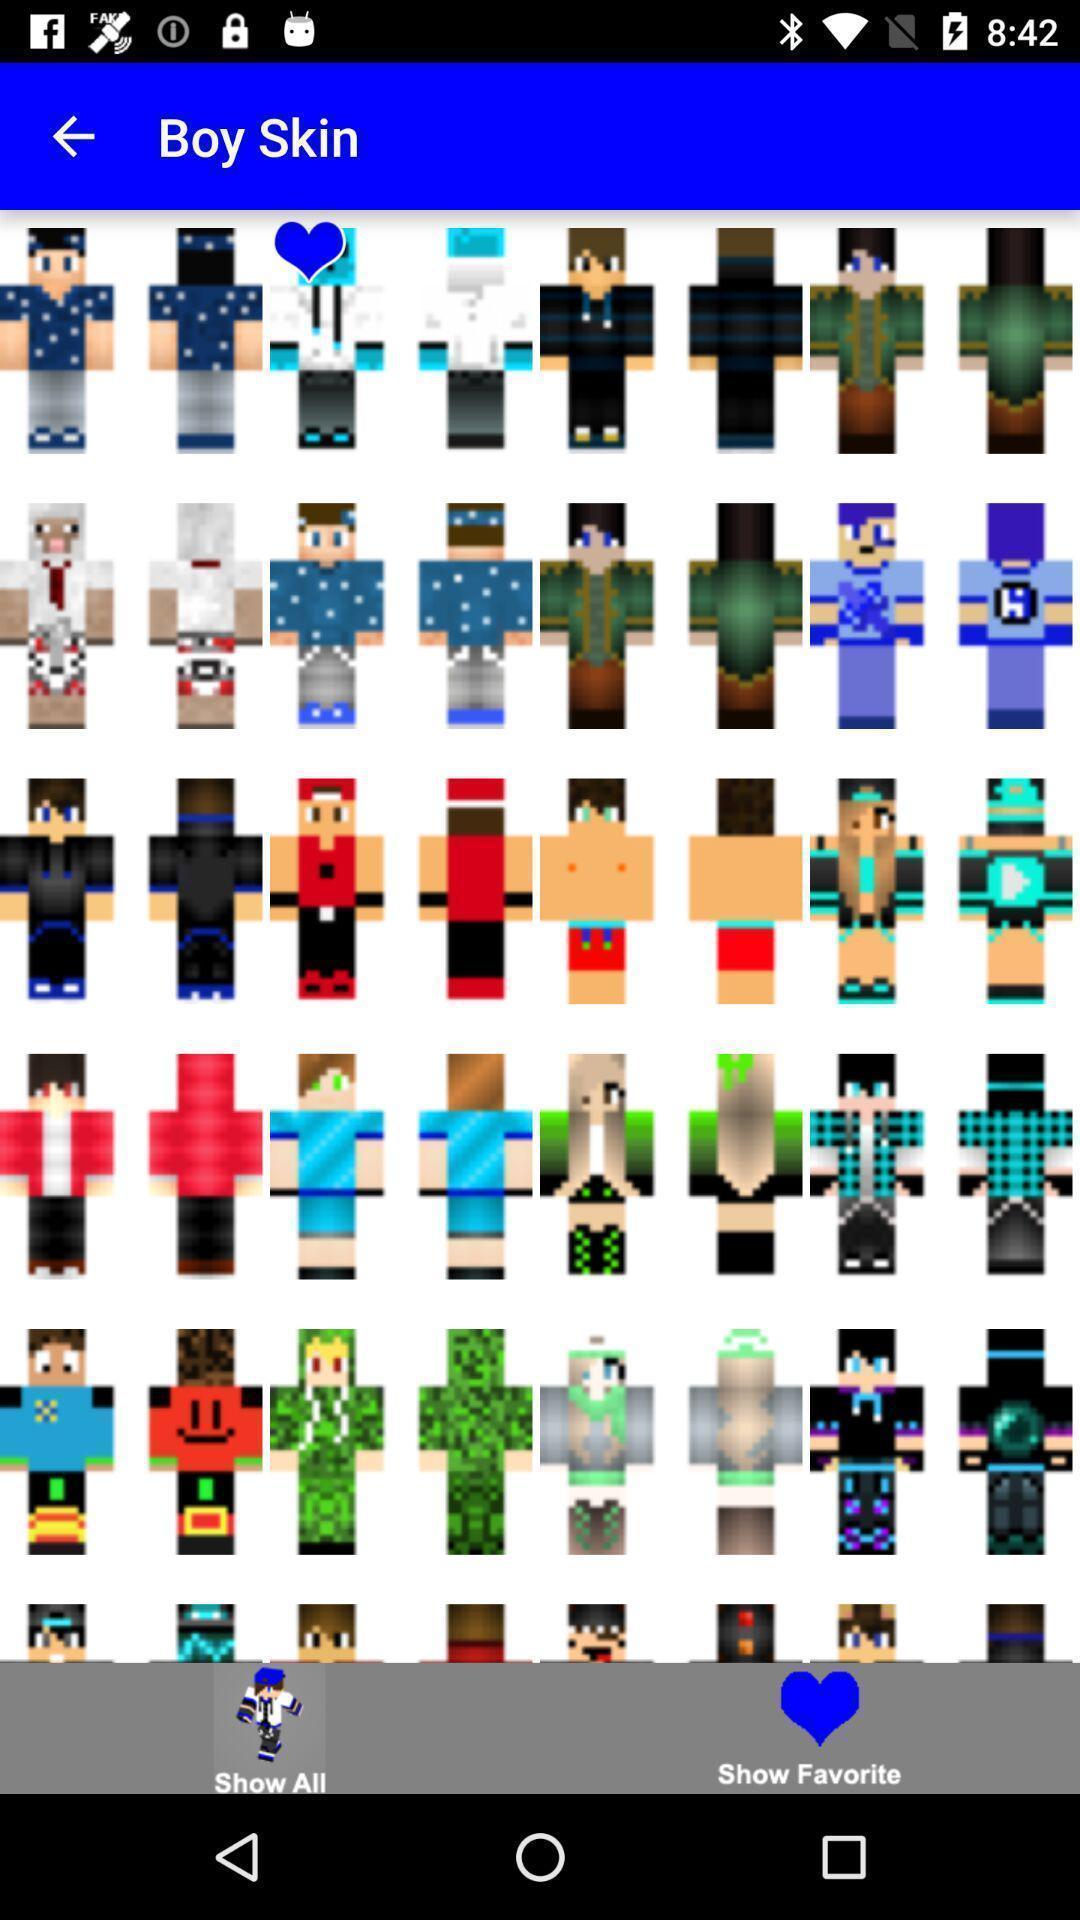Tell me what you see in this picture. Page displaying with different skin options for boy. 